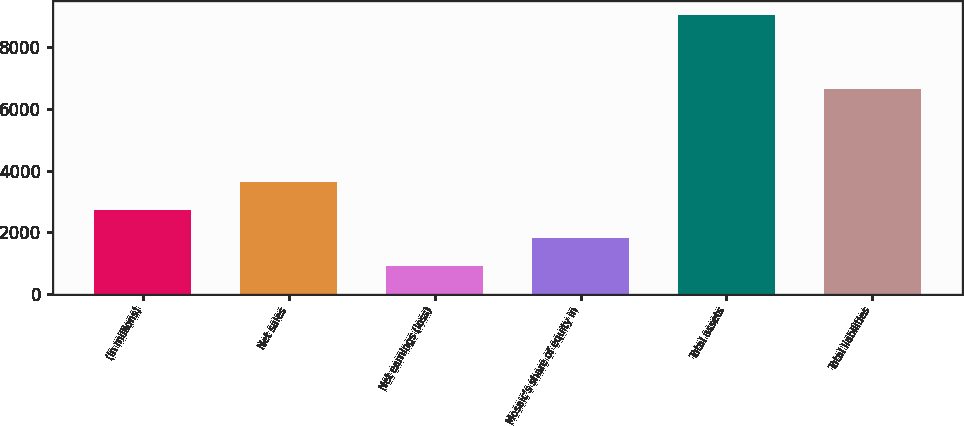Convert chart to OTSL. <chart><loc_0><loc_0><loc_500><loc_500><bar_chart><fcel>(in millions)<fcel>Net sales<fcel>Net earnings (loss)<fcel>Mosaic's share of equity in<fcel>Total assets<fcel>Total liabilities<nl><fcel>2716.02<fcel>3619.86<fcel>908.34<fcel>1812.18<fcel>9042.9<fcel>6658.2<nl></chart> 